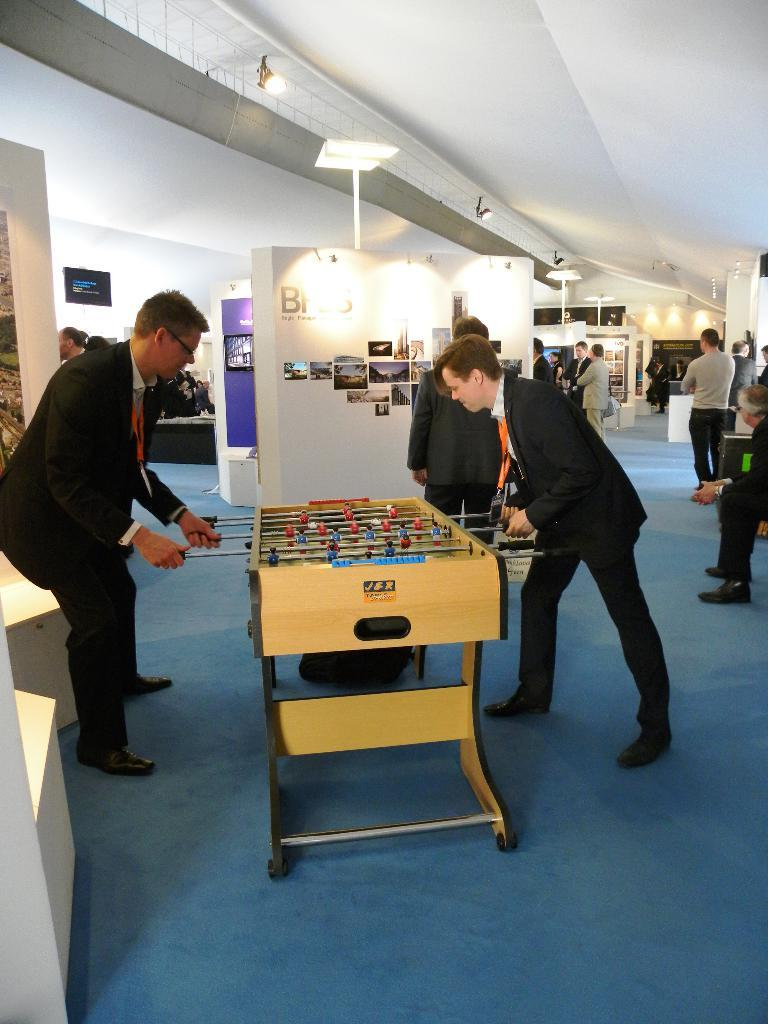What activity are the two persons engaged in? The two persons are playing an indoor football game. What can be seen in the background of the image? There is a wall with photos and light in the background. How many people are present in the background? Many people are present in the background. What is the color of the carpet on the floor? The floor has a blue carpet. What type of sleep can be seen in the image? There is no sleep depicted in the image; it features two persons playing an indoor football game. Can you describe the behavior of the waves in the image? There are no waves present in the image, as it is an indoor setting with a football game being played. 